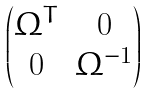Convert formula to latex. <formula><loc_0><loc_0><loc_500><loc_500>\begin{pmatrix} \Omega ^ { T } & 0 \\ 0 & \Omega ^ { - 1 } \end{pmatrix}</formula> 